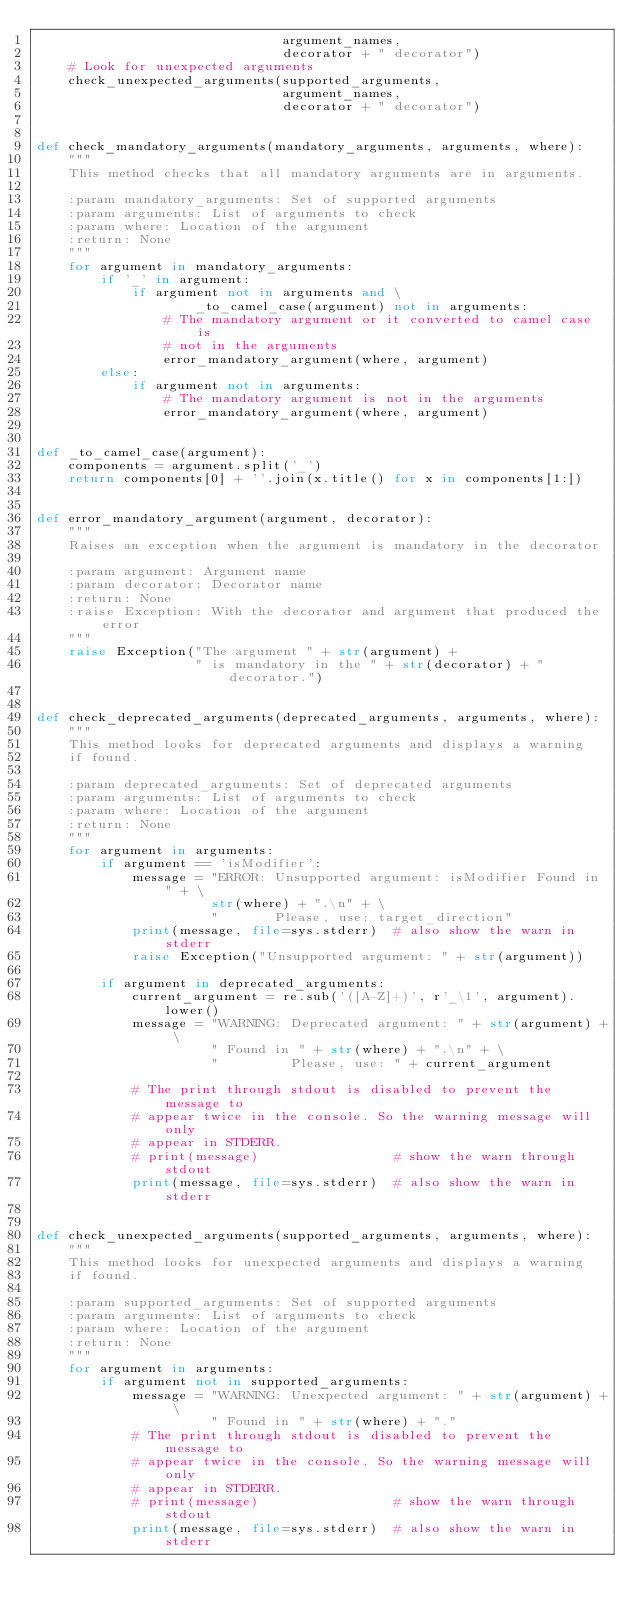<code> <loc_0><loc_0><loc_500><loc_500><_Python_>                               argument_names,
                               decorator + " decorator")
    # Look for unexpected arguments
    check_unexpected_arguments(supported_arguments,
                               argument_names,
                               decorator + " decorator")


def check_mandatory_arguments(mandatory_arguments, arguments, where):
    """
    This method checks that all mandatory arguments are in arguments.

    :param mandatory_arguments: Set of supported arguments
    :param arguments: List of arguments to check
    :param where: Location of the argument
    :return: None
    """
    for argument in mandatory_arguments:
        if '_' in argument:
            if argument not in arguments and \
                    _to_camel_case(argument) not in arguments:
                # The mandatory argument or it converted to camel case is
                # not in the arguments
                error_mandatory_argument(where, argument)
        else:
            if argument not in arguments:
                # The mandatory argument is not in the arguments
                error_mandatory_argument(where, argument)


def _to_camel_case(argument):
    components = argument.split('_')
    return components[0] + ''.join(x.title() for x in components[1:])


def error_mandatory_argument(argument, decorator):
    """
    Raises an exception when the argument is mandatory in the decorator

    :param argument: Argument name
    :param decorator: Decorator name
    :return: None
    :raise Exception: With the decorator and argument that produced the error
    """
    raise Exception("The argument " + str(argument) +
                    " is mandatory in the " + str(decorator) + " decorator.")


def check_deprecated_arguments(deprecated_arguments, arguments, where):
    """
    This method looks for deprecated arguments and displays a warning
    if found.

    :param deprecated_arguments: Set of deprecated arguments
    :param arguments: List of arguments to check
    :param where: Location of the argument
    :return: None
    """
    for argument in arguments:
        if argument == 'isModifier':
            message = "ERROR: Unsupported argument: isModifier Found in " + \
                      str(where) + ".\n" + \
                      "       Please, use: target_direction"
            print(message, file=sys.stderr)  # also show the warn in stderr
            raise Exception("Unsupported argument: " + str(argument))

        if argument in deprecated_arguments:
            current_argument = re.sub('([A-Z]+)', r'_\1', argument).lower()
            message = "WARNING: Deprecated argument: " + str(argument) + \
                      " Found in " + str(where) + ".\n" + \
                      "         Please, use: " + current_argument

            # The print through stdout is disabled to prevent the message to
            # appear twice in the console. So the warning message will only
            # appear in STDERR.
            # print(message)                 # show the warn through stdout
            print(message, file=sys.stderr)  # also show the warn in stderr


def check_unexpected_arguments(supported_arguments, arguments, where):
    """
    This method looks for unexpected arguments and displays a warning
    if found.

    :param supported_arguments: Set of supported arguments
    :param arguments: List of arguments to check
    :param where: Location of the argument
    :return: None
    """
    for argument in arguments:
        if argument not in supported_arguments:
            message = "WARNING: Unexpected argument: " + str(argument) + \
                      " Found in " + str(where) + "."
            # The print through stdout is disabled to prevent the message to
            # appear twice in the console. So the warning message will only
            # appear in STDERR.
            # print(message)                 # show the warn through stdout
            print(message, file=sys.stderr)  # also show the warn in stderr
</code> 